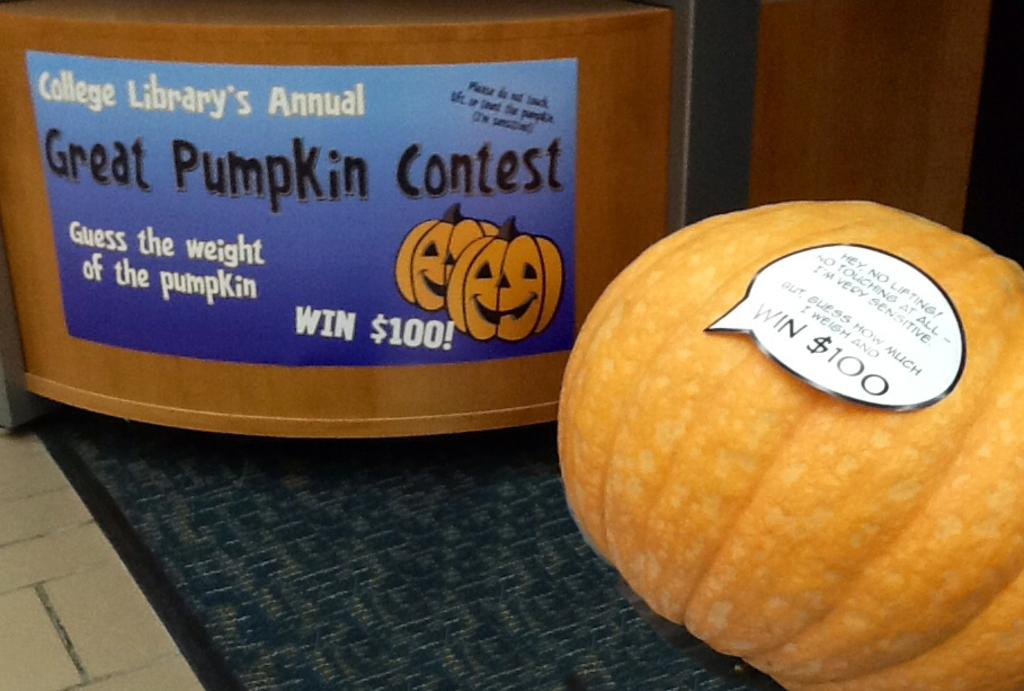What object is located in the bottom right of the image? There is a pumpkin in the bottom right of the image. Is there any additional information about the pumpkin? Yes, there is a tag on the pumpkin. What can be seen in the background of the image? There is a box-like structure in the background of the image. What is on the box-like structure? There is a poster on the box-like structure. What type of flooring is visible in the image? There is a carpet on the floor in the image. How many brothers are depicted in the image? There are no brothers present in the image. What type of jar is visible on the pumpkin? There is no jar present on the pumpkin in the image. 